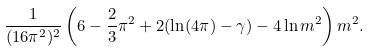Convert formula to latex. <formula><loc_0><loc_0><loc_500><loc_500>\frac { 1 } { ( 1 6 \pi ^ { 2 } ) ^ { 2 } } \left ( 6 - \frac { 2 } { 3 } \pi ^ { 2 } + 2 ( \ln ( 4 \pi ) - \gamma ) - 4 \ln m ^ { 2 } \right ) m ^ { 2 } .</formula> 